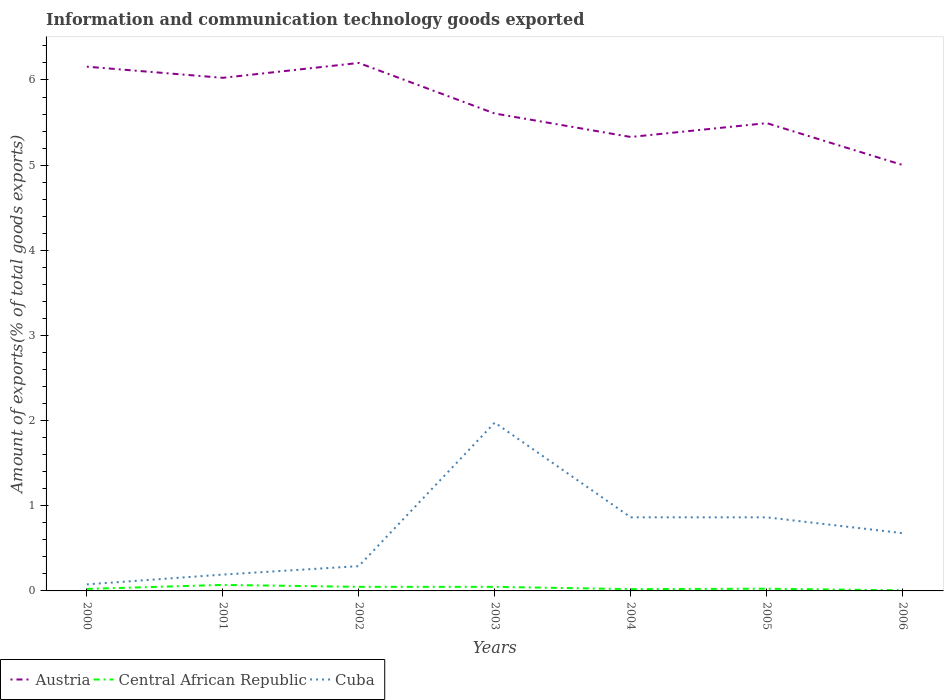Across all years, what is the maximum amount of goods exported in Austria?
Your answer should be compact. 5. In which year was the amount of goods exported in Central African Republic maximum?
Make the answer very short. 2006. What is the total amount of goods exported in Cuba in the graph?
Provide a succinct answer. -0.1. What is the difference between the highest and the second highest amount of goods exported in Austria?
Give a very brief answer. 1.2. Is the amount of goods exported in Cuba strictly greater than the amount of goods exported in Austria over the years?
Keep it short and to the point. Yes. How many lines are there?
Keep it short and to the point. 3. What is the difference between two consecutive major ticks on the Y-axis?
Provide a short and direct response. 1. Are the values on the major ticks of Y-axis written in scientific E-notation?
Provide a succinct answer. No. Does the graph contain any zero values?
Make the answer very short. No. Does the graph contain grids?
Provide a succinct answer. No. Where does the legend appear in the graph?
Provide a short and direct response. Bottom left. How are the legend labels stacked?
Your answer should be compact. Horizontal. What is the title of the graph?
Ensure brevity in your answer.  Information and communication technology goods exported. What is the label or title of the X-axis?
Your answer should be compact. Years. What is the label or title of the Y-axis?
Ensure brevity in your answer.  Amount of exports(% of total goods exports). What is the Amount of exports(% of total goods exports) in Austria in 2000?
Ensure brevity in your answer.  6.16. What is the Amount of exports(% of total goods exports) of Central African Republic in 2000?
Give a very brief answer. 0.02. What is the Amount of exports(% of total goods exports) in Cuba in 2000?
Offer a terse response. 0.08. What is the Amount of exports(% of total goods exports) in Austria in 2001?
Offer a very short reply. 6.03. What is the Amount of exports(% of total goods exports) of Central African Republic in 2001?
Make the answer very short. 0.07. What is the Amount of exports(% of total goods exports) of Cuba in 2001?
Provide a succinct answer. 0.19. What is the Amount of exports(% of total goods exports) in Austria in 2002?
Provide a succinct answer. 6.2. What is the Amount of exports(% of total goods exports) of Central African Republic in 2002?
Offer a very short reply. 0.05. What is the Amount of exports(% of total goods exports) in Cuba in 2002?
Provide a short and direct response. 0.29. What is the Amount of exports(% of total goods exports) of Austria in 2003?
Ensure brevity in your answer.  5.61. What is the Amount of exports(% of total goods exports) in Central African Republic in 2003?
Provide a short and direct response. 0.05. What is the Amount of exports(% of total goods exports) in Cuba in 2003?
Offer a terse response. 1.98. What is the Amount of exports(% of total goods exports) in Austria in 2004?
Provide a short and direct response. 5.33. What is the Amount of exports(% of total goods exports) of Central African Republic in 2004?
Make the answer very short. 0.02. What is the Amount of exports(% of total goods exports) of Cuba in 2004?
Give a very brief answer. 0.86. What is the Amount of exports(% of total goods exports) in Austria in 2005?
Make the answer very short. 5.49. What is the Amount of exports(% of total goods exports) in Central African Republic in 2005?
Provide a short and direct response. 0.03. What is the Amount of exports(% of total goods exports) of Cuba in 2005?
Your answer should be very brief. 0.86. What is the Amount of exports(% of total goods exports) in Austria in 2006?
Offer a very short reply. 5. What is the Amount of exports(% of total goods exports) in Central African Republic in 2006?
Give a very brief answer. 0.01. What is the Amount of exports(% of total goods exports) in Cuba in 2006?
Your answer should be compact. 0.68. Across all years, what is the maximum Amount of exports(% of total goods exports) of Austria?
Offer a terse response. 6.2. Across all years, what is the maximum Amount of exports(% of total goods exports) of Central African Republic?
Ensure brevity in your answer.  0.07. Across all years, what is the maximum Amount of exports(% of total goods exports) of Cuba?
Give a very brief answer. 1.98. Across all years, what is the minimum Amount of exports(% of total goods exports) of Austria?
Give a very brief answer. 5. Across all years, what is the minimum Amount of exports(% of total goods exports) of Central African Republic?
Offer a very short reply. 0.01. Across all years, what is the minimum Amount of exports(% of total goods exports) in Cuba?
Keep it short and to the point. 0.08. What is the total Amount of exports(% of total goods exports) in Austria in the graph?
Provide a short and direct response. 39.81. What is the total Amount of exports(% of total goods exports) of Central African Republic in the graph?
Provide a succinct answer. 0.24. What is the total Amount of exports(% of total goods exports) of Cuba in the graph?
Provide a succinct answer. 4.94. What is the difference between the Amount of exports(% of total goods exports) of Austria in 2000 and that in 2001?
Ensure brevity in your answer.  0.13. What is the difference between the Amount of exports(% of total goods exports) in Central African Republic in 2000 and that in 2001?
Offer a very short reply. -0.05. What is the difference between the Amount of exports(% of total goods exports) of Cuba in 2000 and that in 2001?
Provide a short and direct response. -0.12. What is the difference between the Amount of exports(% of total goods exports) of Austria in 2000 and that in 2002?
Provide a succinct answer. -0.04. What is the difference between the Amount of exports(% of total goods exports) in Central African Republic in 2000 and that in 2002?
Your answer should be compact. -0.02. What is the difference between the Amount of exports(% of total goods exports) of Cuba in 2000 and that in 2002?
Offer a very short reply. -0.21. What is the difference between the Amount of exports(% of total goods exports) in Austria in 2000 and that in 2003?
Offer a terse response. 0.55. What is the difference between the Amount of exports(% of total goods exports) of Central African Republic in 2000 and that in 2003?
Offer a very short reply. -0.02. What is the difference between the Amount of exports(% of total goods exports) in Cuba in 2000 and that in 2003?
Your answer should be very brief. -1.9. What is the difference between the Amount of exports(% of total goods exports) in Austria in 2000 and that in 2004?
Your answer should be very brief. 0.83. What is the difference between the Amount of exports(% of total goods exports) of Central African Republic in 2000 and that in 2004?
Your answer should be very brief. 0. What is the difference between the Amount of exports(% of total goods exports) of Cuba in 2000 and that in 2004?
Your answer should be very brief. -0.79. What is the difference between the Amount of exports(% of total goods exports) in Austria in 2000 and that in 2005?
Offer a terse response. 0.66. What is the difference between the Amount of exports(% of total goods exports) in Central African Republic in 2000 and that in 2005?
Provide a succinct answer. -0. What is the difference between the Amount of exports(% of total goods exports) of Cuba in 2000 and that in 2005?
Your response must be concise. -0.79. What is the difference between the Amount of exports(% of total goods exports) of Austria in 2000 and that in 2006?
Make the answer very short. 1.16. What is the difference between the Amount of exports(% of total goods exports) in Central African Republic in 2000 and that in 2006?
Provide a succinct answer. 0.02. What is the difference between the Amount of exports(% of total goods exports) of Cuba in 2000 and that in 2006?
Your response must be concise. -0.6. What is the difference between the Amount of exports(% of total goods exports) in Austria in 2001 and that in 2002?
Offer a very short reply. -0.17. What is the difference between the Amount of exports(% of total goods exports) in Central African Republic in 2001 and that in 2002?
Your response must be concise. 0.02. What is the difference between the Amount of exports(% of total goods exports) of Cuba in 2001 and that in 2002?
Keep it short and to the point. -0.1. What is the difference between the Amount of exports(% of total goods exports) of Austria in 2001 and that in 2003?
Your response must be concise. 0.42. What is the difference between the Amount of exports(% of total goods exports) of Central African Republic in 2001 and that in 2003?
Offer a very short reply. 0.02. What is the difference between the Amount of exports(% of total goods exports) of Cuba in 2001 and that in 2003?
Keep it short and to the point. -1.78. What is the difference between the Amount of exports(% of total goods exports) in Austria in 2001 and that in 2004?
Provide a short and direct response. 0.69. What is the difference between the Amount of exports(% of total goods exports) in Central African Republic in 2001 and that in 2004?
Make the answer very short. 0.05. What is the difference between the Amount of exports(% of total goods exports) in Cuba in 2001 and that in 2004?
Your answer should be very brief. -0.67. What is the difference between the Amount of exports(% of total goods exports) of Austria in 2001 and that in 2005?
Keep it short and to the point. 0.53. What is the difference between the Amount of exports(% of total goods exports) of Central African Republic in 2001 and that in 2005?
Provide a short and direct response. 0.04. What is the difference between the Amount of exports(% of total goods exports) of Cuba in 2001 and that in 2005?
Provide a short and direct response. -0.67. What is the difference between the Amount of exports(% of total goods exports) of Austria in 2001 and that in 2006?
Offer a very short reply. 1.02. What is the difference between the Amount of exports(% of total goods exports) in Central African Republic in 2001 and that in 2006?
Make the answer very short. 0.06. What is the difference between the Amount of exports(% of total goods exports) in Cuba in 2001 and that in 2006?
Offer a terse response. -0.49. What is the difference between the Amount of exports(% of total goods exports) of Austria in 2002 and that in 2003?
Offer a very short reply. 0.59. What is the difference between the Amount of exports(% of total goods exports) in Cuba in 2002 and that in 2003?
Provide a succinct answer. -1.69. What is the difference between the Amount of exports(% of total goods exports) in Austria in 2002 and that in 2004?
Keep it short and to the point. 0.87. What is the difference between the Amount of exports(% of total goods exports) in Central African Republic in 2002 and that in 2004?
Provide a short and direct response. 0.03. What is the difference between the Amount of exports(% of total goods exports) in Cuba in 2002 and that in 2004?
Your answer should be compact. -0.57. What is the difference between the Amount of exports(% of total goods exports) in Austria in 2002 and that in 2005?
Your answer should be very brief. 0.71. What is the difference between the Amount of exports(% of total goods exports) in Central African Republic in 2002 and that in 2005?
Offer a terse response. 0.02. What is the difference between the Amount of exports(% of total goods exports) in Cuba in 2002 and that in 2005?
Your answer should be compact. -0.57. What is the difference between the Amount of exports(% of total goods exports) of Austria in 2002 and that in 2006?
Your answer should be compact. 1.2. What is the difference between the Amount of exports(% of total goods exports) in Central African Republic in 2002 and that in 2006?
Offer a terse response. 0.04. What is the difference between the Amount of exports(% of total goods exports) of Cuba in 2002 and that in 2006?
Your answer should be compact. -0.39. What is the difference between the Amount of exports(% of total goods exports) in Austria in 2003 and that in 2004?
Offer a very short reply. 0.28. What is the difference between the Amount of exports(% of total goods exports) of Central African Republic in 2003 and that in 2004?
Offer a terse response. 0.03. What is the difference between the Amount of exports(% of total goods exports) in Cuba in 2003 and that in 2004?
Provide a succinct answer. 1.11. What is the difference between the Amount of exports(% of total goods exports) in Austria in 2003 and that in 2005?
Your answer should be very brief. 0.11. What is the difference between the Amount of exports(% of total goods exports) in Central African Republic in 2003 and that in 2005?
Ensure brevity in your answer.  0.02. What is the difference between the Amount of exports(% of total goods exports) in Cuba in 2003 and that in 2005?
Ensure brevity in your answer.  1.11. What is the difference between the Amount of exports(% of total goods exports) of Austria in 2003 and that in 2006?
Your answer should be very brief. 0.6. What is the difference between the Amount of exports(% of total goods exports) of Central African Republic in 2003 and that in 2006?
Your response must be concise. 0.04. What is the difference between the Amount of exports(% of total goods exports) in Cuba in 2003 and that in 2006?
Your answer should be very brief. 1.3. What is the difference between the Amount of exports(% of total goods exports) in Austria in 2004 and that in 2005?
Keep it short and to the point. -0.16. What is the difference between the Amount of exports(% of total goods exports) of Central African Republic in 2004 and that in 2005?
Your answer should be very brief. -0. What is the difference between the Amount of exports(% of total goods exports) in Cuba in 2004 and that in 2005?
Your response must be concise. 0. What is the difference between the Amount of exports(% of total goods exports) in Austria in 2004 and that in 2006?
Offer a terse response. 0.33. What is the difference between the Amount of exports(% of total goods exports) of Central African Republic in 2004 and that in 2006?
Make the answer very short. 0.01. What is the difference between the Amount of exports(% of total goods exports) in Cuba in 2004 and that in 2006?
Your answer should be compact. 0.19. What is the difference between the Amount of exports(% of total goods exports) in Austria in 2005 and that in 2006?
Ensure brevity in your answer.  0.49. What is the difference between the Amount of exports(% of total goods exports) in Central African Republic in 2005 and that in 2006?
Provide a succinct answer. 0.02. What is the difference between the Amount of exports(% of total goods exports) in Cuba in 2005 and that in 2006?
Keep it short and to the point. 0.19. What is the difference between the Amount of exports(% of total goods exports) in Austria in 2000 and the Amount of exports(% of total goods exports) in Central African Republic in 2001?
Provide a short and direct response. 6.09. What is the difference between the Amount of exports(% of total goods exports) of Austria in 2000 and the Amount of exports(% of total goods exports) of Cuba in 2001?
Give a very brief answer. 5.96. What is the difference between the Amount of exports(% of total goods exports) in Central African Republic in 2000 and the Amount of exports(% of total goods exports) in Cuba in 2001?
Provide a succinct answer. -0.17. What is the difference between the Amount of exports(% of total goods exports) of Austria in 2000 and the Amount of exports(% of total goods exports) of Central African Republic in 2002?
Ensure brevity in your answer.  6.11. What is the difference between the Amount of exports(% of total goods exports) in Austria in 2000 and the Amount of exports(% of total goods exports) in Cuba in 2002?
Keep it short and to the point. 5.87. What is the difference between the Amount of exports(% of total goods exports) in Central African Republic in 2000 and the Amount of exports(% of total goods exports) in Cuba in 2002?
Provide a short and direct response. -0.27. What is the difference between the Amount of exports(% of total goods exports) in Austria in 2000 and the Amount of exports(% of total goods exports) in Central African Republic in 2003?
Your answer should be compact. 6.11. What is the difference between the Amount of exports(% of total goods exports) of Austria in 2000 and the Amount of exports(% of total goods exports) of Cuba in 2003?
Give a very brief answer. 4.18. What is the difference between the Amount of exports(% of total goods exports) in Central African Republic in 2000 and the Amount of exports(% of total goods exports) in Cuba in 2003?
Offer a terse response. -1.95. What is the difference between the Amount of exports(% of total goods exports) of Austria in 2000 and the Amount of exports(% of total goods exports) of Central African Republic in 2004?
Your response must be concise. 6.14. What is the difference between the Amount of exports(% of total goods exports) in Austria in 2000 and the Amount of exports(% of total goods exports) in Cuba in 2004?
Give a very brief answer. 5.29. What is the difference between the Amount of exports(% of total goods exports) in Central African Republic in 2000 and the Amount of exports(% of total goods exports) in Cuba in 2004?
Offer a very short reply. -0.84. What is the difference between the Amount of exports(% of total goods exports) of Austria in 2000 and the Amount of exports(% of total goods exports) of Central African Republic in 2005?
Ensure brevity in your answer.  6.13. What is the difference between the Amount of exports(% of total goods exports) of Austria in 2000 and the Amount of exports(% of total goods exports) of Cuba in 2005?
Provide a short and direct response. 5.29. What is the difference between the Amount of exports(% of total goods exports) of Central African Republic in 2000 and the Amount of exports(% of total goods exports) of Cuba in 2005?
Your response must be concise. -0.84. What is the difference between the Amount of exports(% of total goods exports) in Austria in 2000 and the Amount of exports(% of total goods exports) in Central African Republic in 2006?
Offer a very short reply. 6.15. What is the difference between the Amount of exports(% of total goods exports) of Austria in 2000 and the Amount of exports(% of total goods exports) of Cuba in 2006?
Your response must be concise. 5.48. What is the difference between the Amount of exports(% of total goods exports) of Central African Republic in 2000 and the Amount of exports(% of total goods exports) of Cuba in 2006?
Your answer should be compact. -0.65. What is the difference between the Amount of exports(% of total goods exports) of Austria in 2001 and the Amount of exports(% of total goods exports) of Central African Republic in 2002?
Ensure brevity in your answer.  5.98. What is the difference between the Amount of exports(% of total goods exports) in Austria in 2001 and the Amount of exports(% of total goods exports) in Cuba in 2002?
Offer a terse response. 5.73. What is the difference between the Amount of exports(% of total goods exports) in Central African Republic in 2001 and the Amount of exports(% of total goods exports) in Cuba in 2002?
Offer a very short reply. -0.22. What is the difference between the Amount of exports(% of total goods exports) of Austria in 2001 and the Amount of exports(% of total goods exports) of Central African Republic in 2003?
Make the answer very short. 5.98. What is the difference between the Amount of exports(% of total goods exports) of Austria in 2001 and the Amount of exports(% of total goods exports) of Cuba in 2003?
Your answer should be compact. 4.05. What is the difference between the Amount of exports(% of total goods exports) in Central African Republic in 2001 and the Amount of exports(% of total goods exports) in Cuba in 2003?
Offer a very short reply. -1.91. What is the difference between the Amount of exports(% of total goods exports) in Austria in 2001 and the Amount of exports(% of total goods exports) in Central African Republic in 2004?
Ensure brevity in your answer.  6. What is the difference between the Amount of exports(% of total goods exports) in Austria in 2001 and the Amount of exports(% of total goods exports) in Cuba in 2004?
Offer a terse response. 5.16. What is the difference between the Amount of exports(% of total goods exports) in Central African Republic in 2001 and the Amount of exports(% of total goods exports) in Cuba in 2004?
Offer a very short reply. -0.79. What is the difference between the Amount of exports(% of total goods exports) in Austria in 2001 and the Amount of exports(% of total goods exports) in Central African Republic in 2005?
Offer a terse response. 6. What is the difference between the Amount of exports(% of total goods exports) in Austria in 2001 and the Amount of exports(% of total goods exports) in Cuba in 2005?
Give a very brief answer. 5.16. What is the difference between the Amount of exports(% of total goods exports) in Central African Republic in 2001 and the Amount of exports(% of total goods exports) in Cuba in 2005?
Give a very brief answer. -0.79. What is the difference between the Amount of exports(% of total goods exports) in Austria in 2001 and the Amount of exports(% of total goods exports) in Central African Republic in 2006?
Keep it short and to the point. 6.02. What is the difference between the Amount of exports(% of total goods exports) in Austria in 2001 and the Amount of exports(% of total goods exports) in Cuba in 2006?
Provide a succinct answer. 5.35. What is the difference between the Amount of exports(% of total goods exports) in Central African Republic in 2001 and the Amount of exports(% of total goods exports) in Cuba in 2006?
Offer a very short reply. -0.61. What is the difference between the Amount of exports(% of total goods exports) of Austria in 2002 and the Amount of exports(% of total goods exports) of Central African Republic in 2003?
Your response must be concise. 6.15. What is the difference between the Amount of exports(% of total goods exports) of Austria in 2002 and the Amount of exports(% of total goods exports) of Cuba in 2003?
Keep it short and to the point. 4.22. What is the difference between the Amount of exports(% of total goods exports) in Central African Republic in 2002 and the Amount of exports(% of total goods exports) in Cuba in 2003?
Ensure brevity in your answer.  -1.93. What is the difference between the Amount of exports(% of total goods exports) in Austria in 2002 and the Amount of exports(% of total goods exports) in Central African Republic in 2004?
Your answer should be compact. 6.18. What is the difference between the Amount of exports(% of total goods exports) of Austria in 2002 and the Amount of exports(% of total goods exports) of Cuba in 2004?
Provide a succinct answer. 5.34. What is the difference between the Amount of exports(% of total goods exports) of Central African Republic in 2002 and the Amount of exports(% of total goods exports) of Cuba in 2004?
Offer a terse response. -0.82. What is the difference between the Amount of exports(% of total goods exports) of Austria in 2002 and the Amount of exports(% of total goods exports) of Central African Republic in 2005?
Provide a short and direct response. 6.17. What is the difference between the Amount of exports(% of total goods exports) of Austria in 2002 and the Amount of exports(% of total goods exports) of Cuba in 2005?
Your answer should be compact. 5.34. What is the difference between the Amount of exports(% of total goods exports) in Central African Republic in 2002 and the Amount of exports(% of total goods exports) in Cuba in 2005?
Provide a succinct answer. -0.82. What is the difference between the Amount of exports(% of total goods exports) of Austria in 2002 and the Amount of exports(% of total goods exports) of Central African Republic in 2006?
Keep it short and to the point. 6.19. What is the difference between the Amount of exports(% of total goods exports) of Austria in 2002 and the Amount of exports(% of total goods exports) of Cuba in 2006?
Offer a terse response. 5.52. What is the difference between the Amount of exports(% of total goods exports) in Central African Republic in 2002 and the Amount of exports(% of total goods exports) in Cuba in 2006?
Offer a very short reply. -0.63. What is the difference between the Amount of exports(% of total goods exports) in Austria in 2003 and the Amount of exports(% of total goods exports) in Central African Republic in 2004?
Your answer should be compact. 5.59. What is the difference between the Amount of exports(% of total goods exports) in Austria in 2003 and the Amount of exports(% of total goods exports) in Cuba in 2004?
Provide a short and direct response. 4.74. What is the difference between the Amount of exports(% of total goods exports) in Central African Republic in 2003 and the Amount of exports(% of total goods exports) in Cuba in 2004?
Make the answer very short. -0.82. What is the difference between the Amount of exports(% of total goods exports) in Austria in 2003 and the Amount of exports(% of total goods exports) in Central African Republic in 2005?
Provide a short and direct response. 5.58. What is the difference between the Amount of exports(% of total goods exports) of Austria in 2003 and the Amount of exports(% of total goods exports) of Cuba in 2005?
Provide a short and direct response. 4.74. What is the difference between the Amount of exports(% of total goods exports) of Central African Republic in 2003 and the Amount of exports(% of total goods exports) of Cuba in 2005?
Ensure brevity in your answer.  -0.82. What is the difference between the Amount of exports(% of total goods exports) of Austria in 2003 and the Amount of exports(% of total goods exports) of Central African Republic in 2006?
Your response must be concise. 5.6. What is the difference between the Amount of exports(% of total goods exports) of Austria in 2003 and the Amount of exports(% of total goods exports) of Cuba in 2006?
Your answer should be compact. 4.93. What is the difference between the Amount of exports(% of total goods exports) in Central African Republic in 2003 and the Amount of exports(% of total goods exports) in Cuba in 2006?
Provide a short and direct response. -0.63. What is the difference between the Amount of exports(% of total goods exports) of Austria in 2004 and the Amount of exports(% of total goods exports) of Central African Republic in 2005?
Provide a succinct answer. 5.3. What is the difference between the Amount of exports(% of total goods exports) of Austria in 2004 and the Amount of exports(% of total goods exports) of Cuba in 2005?
Your response must be concise. 4.47. What is the difference between the Amount of exports(% of total goods exports) in Central African Republic in 2004 and the Amount of exports(% of total goods exports) in Cuba in 2005?
Offer a very short reply. -0.84. What is the difference between the Amount of exports(% of total goods exports) of Austria in 2004 and the Amount of exports(% of total goods exports) of Central African Republic in 2006?
Your answer should be very brief. 5.32. What is the difference between the Amount of exports(% of total goods exports) of Austria in 2004 and the Amount of exports(% of total goods exports) of Cuba in 2006?
Your answer should be very brief. 4.65. What is the difference between the Amount of exports(% of total goods exports) in Central African Republic in 2004 and the Amount of exports(% of total goods exports) in Cuba in 2006?
Your answer should be compact. -0.66. What is the difference between the Amount of exports(% of total goods exports) of Austria in 2005 and the Amount of exports(% of total goods exports) of Central African Republic in 2006?
Offer a very short reply. 5.49. What is the difference between the Amount of exports(% of total goods exports) in Austria in 2005 and the Amount of exports(% of total goods exports) in Cuba in 2006?
Your answer should be compact. 4.82. What is the difference between the Amount of exports(% of total goods exports) of Central African Republic in 2005 and the Amount of exports(% of total goods exports) of Cuba in 2006?
Your answer should be very brief. -0.65. What is the average Amount of exports(% of total goods exports) in Austria per year?
Keep it short and to the point. 5.69. What is the average Amount of exports(% of total goods exports) in Central African Republic per year?
Keep it short and to the point. 0.03. What is the average Amount of exports(% of total goods exports) of Cuba per year?
Make the answer very short. 0.71. In the year 2000, what is the difference between the Amount of exports(% of total goods exports) of Austria and Amount of exports(% of total goods exports) of Central African Republic?
Provide a succinct answer. 6.13. In the year 2000, what is the difference between the Amount of exports(% of total goods exports) in Austria and Amount of exports(% of total goods exports) in Cuba?
Offer a terse response. 6.08. In the year 2000, what is the difference between the Amount of exports(% of total goods exports) of Central African Republic and Amount of exports(% of total goods exports) of Cuba?
Provide a short and direct response. -0.05. In the year 2001, what is the difference between the Amount of exports(% of total goods exports) of Austria and Amount of exports(% of total goods exports) of Central African Republic?
Make the answer very short. 5.95. In the year 2001, what is the difference between the Amount of exports(% of total goods exports) in Austria and Amount of exports(% of total goods exports) in Cuba?
Provide a succinct answer. 5.83. In the year 2001, what is the difference between the Amount of exports(% of total goods exports) of Central African Republic and Amount of exports(% of total goods exports) of Cuba?
Make the answer very short. -0.12. In the year 2002, what is the difference between the Amount of exports(% of total goods exports) in Austria and Amount of exports(% of total goods exports) in Central African Republic?
Make the answer very short. 6.15. In the year 2002, what is the difference between the Amount of exports(% of total goods exports) of Austria and Amount of exports(% of total goods exports) of Cuba?
Offer a terse response. 5.91. In the year 2002, what is the difference between the Amount of exports(% of total goods exports) in Central African Republic and Amount of exports(% of total goods exports) in Cuba?
Provide a succinct answer. -0.24. In the year 2003, what is the difference between the Amount of exports(% of total goods exports) of Austria and Amount of exports(% of total goods exports) of Central African Republic?
Provide a short and direct response. 5.56. In the year 2003, what is the difference between the Amount of exports(% of total goods exports) of Austria and Amount of exports(% of total goods exports) of Cuba?
Give a very brief answer. 3.63. In the year 2003, what is the difference between the Amount of exports(% of total goods exports) in Central African Republic and Amount of exports(% of total goods exports) in Cuba?
Your answer should be compact. -1.93. In the year 2004, what is the difference between the Amount of exports(% of total goods exports) of Austria and Amount of exports(% of total goods exports) of Central African Republic?
Provide a short and direct response. 5.31. In the year 2004, what is the difference between the Amount of exports(% of total goods exports) in Austria and Amount of exports(% of total goods exports) in Cuba?
Provide a succinct answer. 4.47. In the year 2004, what is the difference between the Amount of exports(% of total goods exports) of Central African Republic and Amount of exports(% of total goods exports) of Cuba?
Make the answer very short. -0.84. In the year 2005, what is the difference between the Amount of exports(% of total goods exports) of Austria and Amount of exports(% of total goods exports) of Central African Republic?
Your response must be concise. 5.47. In the year 2005, what is the difference between the Amount of exports(% of total goods exports) in Austria and Amount of exports(% of total goods exports) in Cuba?
Provide a short and direct response. 4.63. In the year 2005, what is the difference between the Amount of exports(% of total goods exports) in Central African Republic and Amount of exports(% of total goods exports) in Cuba?
Keep it short and to the point. -0.84. In the year 2006, what is the difference between the Amount of exports(% of total goods exports) of Austria and Amount of exports(% of total goods exports) of Central African Republic?
Your response must be concise. 4.99. In the year 2006, what is the difference between the Amount of exports(% of total goods exports) of Austria and Amount of exports(% of total goods exports) of Cuba?
Keep it short and to the point. 4.32. In the year 2006, what is the difference between the Amount of exports(% of total goods exports) of Central African Republic and Amount of exports(% of total goods exports) of Cuba?
Provide a short and direct response. -0.67. What is the ratio of the Amount of exports(% of total goods exports) of Austria in 2000 to that in 2001?
Give a very brief answer. 1.02. What is the ratio of the Amount of exports(% of total goods exports) of Central African Republic in 2000 to that in 2001?
Provide a succinct answer. 0.34. What is the ratio of the Amount of exports(% of total goods exports) in Cuba in 2000 to that in 2001?
Keep it short and to the point. 0.4. What is the ratio of the Amount of exports(% of total goods exports) of Austria in 2000 to that in 2002?
Provide a succinct answer. 0.99. What is the ratio of the Amount of exports(% of total goods exports) of Central African Republic in 2000 to that in 2002?
Keep it short and to the point. 0.49. What is the ratio of the Amount of exports(% of total goods exports) in Cuba in 2000 to that in 2002?
Offer a terse response. 0.26. What is the ratio of the Amount of exports(% of total goods exports) in Austria in 2000 to that in 2003?
Keep it short and to the point. 1.1. What is the ratio of the Amount of exports(% of total goods exports) of Central African Republic in 2000 to that in 2003?
Offer a very short reply. 0.49. What is the ratio of the Amount of exports(% of total goods exports) in Cuba in 2000 to that in 2003?
Provide a short and direct response. 0.04. What is the ratio of the Amount of exports(% of total goods exports) in Austria in 2000 to that in 2004?
Keep it short and to the point. 1.15. What is the ratio of the Amount of exports(% of total goods exports) in Central African Republic in 2000 to that in 2004?
Keep it short and to the point. 1.12. What is the ratio of the Amount of exports(% of total goods exports) of Cuba in 2000 to that in 2004?
Provide a short and direct response. 0.09. What is the ratio of the Amount of exports(% of total goods exports) in Austria in 2000 to that in 2005?
Keep it short and to the point. 1.12. What is the ratio of the Amount of exports(% of total goods exports) in Central African Republic in 2000 to that in 2005?
Your answer should be very brief. 0.92. What is the ratio of the Amount of exports(% of total goods exports) of Cuba in 2000 to that in 2005?
Keep it short and to the point. 0.09. What is the ratio of the Amount of exports(% of total goods exports) of Austria in 2000 to that in 2006?
Your answer should be compact. 1.23. What is the ratio of the Amount of exports(% of total goods exports) in Central African Republic in 2000 to that in 2006?
Offer a very short reply. 3.26. What is the ratio of the Amount of exports(% of total goods exports) in Cuba in 2000 to that in 2006?
Keep it short and to the point. 0.11. What is the ratio of the Amount of exports(% of total goods exports) of Austria in 2001 to that in 2002?
Provide a succinct answer. 0.97. What is the ratio of the Amount of exports(% of total goods exports) in Central African Republic in 2001 to that in 2002?
Provide a short and direct response. 1.47. What is the ratio of the Amount of exports(% of total goods exports) of Cuba in 2001 to that in 2002?
Your answer should be very brief. 0.66. What is the ratio of the Amount of exports(% of total goods exports) in Austria in 2001 to that in 2003?
Keep it short and to the point. 1.07. What is the ratio of the Amount of exports(% of total goods exports) of Central African Republic in 2001 to that in 2003?
Your answer should be compact. 1.47. What is the ratio of the Amount of exports(% of total goods exports) of Cuba in 2001 to that in 2003?
Offer a very short reply. 0.1. What is the ratio of the Amount of exports(% of total goods exports) of Austria in 2001 to that in 2004?
Your answer should be very brief. 1.13. What is the ratio of the Amount of exports(% of total goods exports) in Central African Republic in 2001 to that in 2004?
Your answer should be very brief. 3.35. What is the ratio of the Amount of exports(% of total goods exports) of Cuba in 2001 to that in 2004?
Keep it short and to the point. 0.22. What is the ratio of the Amount of exports(% of total goods exports) in Austria in 2001 to that in 2005?
Your answer should be very brief. 1.1. What is the ratio of the Amount of exports(% of total goods exports) of Central African Republic in 2001 to that in 2005?
Offer a very short reply. 2.74. What is the ratio of the Amount of exports(% of total goods exports) in Cuba in 2001 to that in 2005?
Give a very brief answer. 0.22. What is the ratio of the Amount of exports(% of total goods exports) in Austria in 2001 to that in 2006?
Give a very brief answer. 1.2. What is the ratio of the Amount of exports(% of total goods exports) in Central African Republic in 2001 to that in 2006?
Your response must be concise. 9.73. What is the ratio of the Amount of exports(% of total goods exports) in Cuba in 2001 to that in 2006?
Make the answer very short. 0.28. What is the ratio of the Amount of exports(% of total goods exports) of Austria in 2002 to that in 2003?
Provide a short and direct response. 1.11. What is the ratio of the Amount of exports(% of total goods exports) in Cuba in 2002 to that in 2003?
Ensure brevity in your answer.  0.15. What is the ratio of the Amount of exports(% of total goods exports) of Austria in 2002 to that in 2004?
Provide a succinct answer. 1.16. What is the ratio of the Amount of exports(% of total goods exports) of Central African Republic in 2002 to that in 2004?
Provide a succinct answer. 2.28. What is the ratio of the Amount of exports(% of total goods exports) in Cuba in 2002 to that in 2004?
Ensure brevity in your answer.  0.34. What is the ratio of the Amount of exports(% of total goods exports) of Austria in 2002 to that in 2005?
Keep it short and to the point. 1.13. What is the ratio of the Amount of exports(% of total goods exports) in Central African Republic in 2002 to that in 2005?
Your answer should be compact. 1.87. What is the ratio of the Amount of exports(% of total goods exports) in Cuba in 2002 to that in 2005?
Make the answer very short. 0.34. What is the ratio of the Amount of exports(% of total goods exports) in Austria in 2002 to that in 2006?
Provide a succinct answer. 1.24. What is the ratio of the Amount of exports(% of total goods exports) in Central African Republic in 2002 to that in 2006?
Your answer should be compact. 6.62. What is the ratio of the Amount of exports(% of total goods exports) in Cuba in 2002 to that in 2006?
Your response must be concise. 0.43. What is the ratio of the Amount of exports(% of total goods exports) of Austria in 2003 to that in 2004?
Ensure brevity in your answer.  1.05. What is the ratio of the Amount of exports(% of total goods exports) of Central African Republic in 2003 to that in 2004?
Ensure brevity in your answer.  2.27. What is the ratio of the Amount of exports(% of total goods exports) in Cuba in 2003 to that in 2004?
Your response must be concise. 2.29. What is the ratio of the Amount of exports(% of total goods exports) of Austria in 2003 to that in 2005?
Offer a very short reply. 1.02. What is the ratio of the Amount of exports(% of total goods exports) in Central African Republic in 2003 to that in 2005?
Give a very brief answer. 1.86. What is the ratio of the Amount of exports(% of total goods exports) of Cuba in 2003 to that in 2005?
Make the answer very short. 2.29. What is the ratio of the Amount of exports(% of total goods exports) of Austria in 2003 to that in 2006?
Give a very brief answer. 1.12. What is the ratio of the Amount of exports(% of total goods exports) of Central African Republic in 2003 to that in 2006?
Your answer should be compact. 6.6. What is the ratio of the Amount of exports(% of total goods exports) of Cuba in 2003 to that in 2006?
Give a very brief answer. 2.91. What is the ratio of the Amount of exports(% of total goods exports) in Austria in 2004 to that in 2005?
Keep it short and to the point. 0.97. What is the ratio of the Amount of exports(% of total goods exports) in Central African Republic in 2004 to that in 2005?
Keep it short and to the point. 0.82. What is the ratio of the Amount of exports(% of total goods exports) of Austria in 2004 to that in 2006?
Keep it short and to the point. 1.07. What is the ratio of the Amount of exports(% of total goods exports) of Central African Republic in 2004 to that in 2006?
Give a very brief answer. 2.9. What is the ratio of the Amount of exports(% of total goods exports) in Cuba in 2004 to that in 2006?
Ensure brevity in your answer.  1.27. What is the ratio of the Amount of exports(% of total goods exports) of Austria in 2005 to that in 2006?
Your answer should be compact. 1.1. What is the ratio of the Amount of exports(% of total goods exports) in Central African Republic in 2005 to that in 2006?
Provide a succinct answer. 3.55. What is the ratio of the Amount of exports(% of total goods exports) of Cuba in 2005 to that in 2006?
Offer a very short reply. 1.27. What is the difference between the highest and the second highest Amount of exports(% of total goods exports) in Austria?
Provide a succinct answer. 0.04. What is the difference between the highest and the second highest Amount of exports(% of total goods exports) of Central African Republic?
Provide a short and direct response. 0.02. What is the difference between the highest and the second highest Amount of exports(% of total goods exports) of Cuba?
Keep it short and to the point. 1.11. What is the difference between the highest and the lowest Amount of exports(% of total goods exports) of Austria?
Your answer should be compact. 1.2. What is the difference between the highest and the lowest Amount of exports(% of total goods exports) in Central African Republic?
Keep it short and to the point. 0.06. What is the difference between the highest and the lowest Amount of exports(% of total goods exports) in Cuba?
Keep it short and to the point. 1.9. 